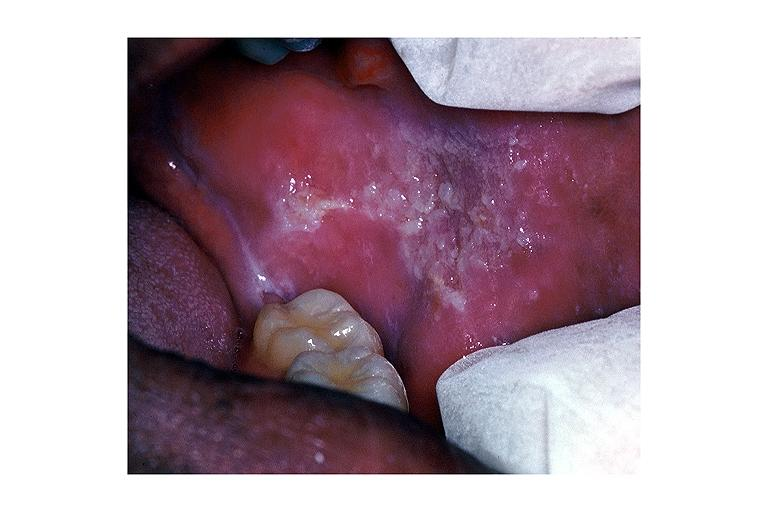what is present?
Answer the question using a single word or phrase. Oral 